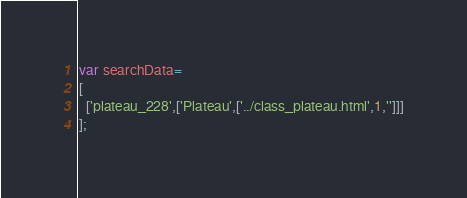Convert code to text. <code><loc_0><loc_0><loc_500><loc_500><_JavaScript_>var searchData=
[
  ['plateau_228',['Plateau',['../class_plateau.html',1,'']]]
];
</code> 